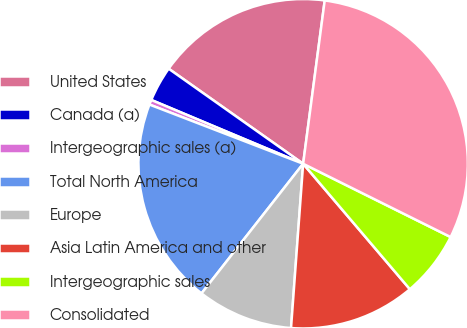<chart> <loc_0><loc_0><loc_500><loc_500><pie_chart><fcel>United States<fcel>Canada (a)<fcel>Intergeographic sales (a)<fcel>Total North America<fcel>Europe<fcel>Asia Latin America and other<fcel>Intergeographic sales<fcel>Consolidated<nl><fcel>17.3%<fcel>3.46%<fcel>0.48%<fcel>20.27%<fcel>9.41%<fcel>12.39%<fcel>6.44%<fcel>30.25%<nl></chart> 